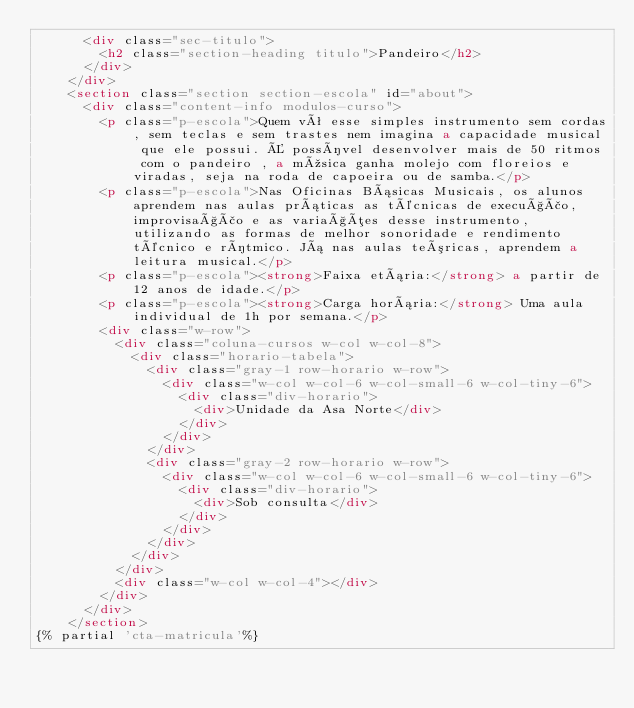Convert code to text. <code><loc_0><loc_0><loc_500><loc_500><_HTML_>      <div class="sec-titulo">
        <h2 class="section-heading titulo">Pandeiro</h2>
      </div>
    </div>
    <section class="section section-escola" id="about">
      <div class="content-info modulos-curso">
        <p class="p-escola">Quem vê esse simples instrumento sem cordas, sem teclas e sem trastes nem imagina a capacidade musical que ele possui. É possível desenvolver mais de 50 ritmos com o pandeiro , a música ganha molejo com floreios e viradas, seja na roda de capoeira ou de samba.</p>
        <p class="p-escola">Nas Oficinas Básicas Musicais, os alunos aprendem nas aulas práticas as técnicas de execução, improvisação e as variações desse instrumento, utilizando as formas de melhor sonoridade e rendimento técnico e rítmico. Já nas aulas teóricas, aprendem a leitura musical.</p>
        <p class="p-escola"><strong>Faixa etária:</strong> a partir de 12 anos de idade.</p>
        <p class="p-escola"><strong>Carga horária:</strong> Uma aula individual de 1h por semana.</p>
        <div class="w-row">
          <div class="coluna-cursos w-col w-col-8">
            <div class="horario-tabela">
              <div class="gray-1 row-horario w-row">
                <div class="w-col w-col-6 w-col-small-6 w-col-tiny-6">
                  <div class="div-horario">
                    <div>Unidade da Asa Norte</div>
                  </div>
                </div>
              </div>
              <div class="gray-2 row-horario w-row">
                <div class="w-col w-col-6 w-col-small-6 w-col-tiny-6">
                  <div class="div-horario">
                    <div>Sob consulta</div>
                  </div>
                </div>
              </div>
            </div>
          </div>
          <div class="w-col w-col-4"></div>
        </div>
      </div>
    </section>
{% partial 'cta-matricula'%}</code> 